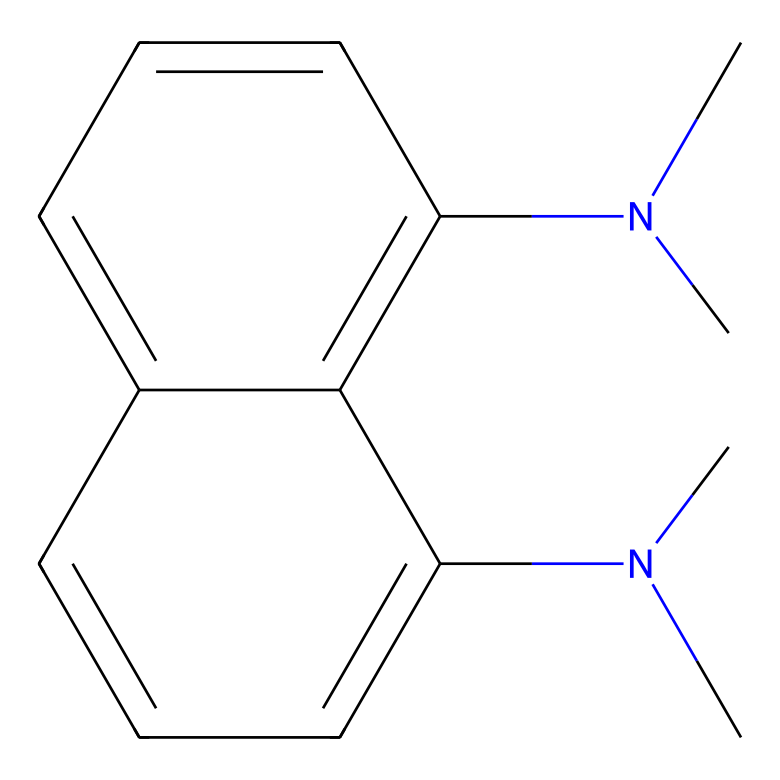What is the molecular formula of this chemical? To determine the molecular formula, count the number of carbon (C), hydrogen (H), and nitrogen (N) atoms from the chemical structure. This molecule contains 14 carbon atoms, 18 hydrogen atoms, and 2 nitrogen atoms. Therefore, the molecular formula is C14H18N2.
Answer: C14H18N2 How many nitrogen atoms are present in the chemical structure? The chemical structure contains two nitrogen atoms, which can be identified by the two 'N' symbols in the SMILES representation.
Answer: 2 What is the functional group associated with this chemical? The presence of nitrogen atoms suggests the functional group is amine. Amine groups have nitrogen atoms that are bonded to carbon atoms and are characteristic of superbases.
Answer: amine Is this chemical likely to be a proton sponge? Examining the structure reveals that the molecule has several regions where it can accept protons due to the basic nature of the amine groups; this suggests it is indeed a proton sponge.
Answer: yes How does this chemical perform in acid-base reactions? The two nitrogen atoms can accept protons, making this chemical a strong base. In acid-base reactions, it can effectively neutralize acids, which is a characteristic of superbases.
Answer: strong base What application might this chemical have in cleaning solutions? Given its strong basicity and structure, this chemical can act as an efficient cleaning agent, particularly in formulations requiring a strong base to remove stains or organic compounds.
Answer: cleaning agent 